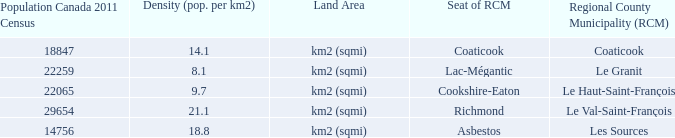What is the RCM that has a density of 9.7? Le Haut-Saint-François. 